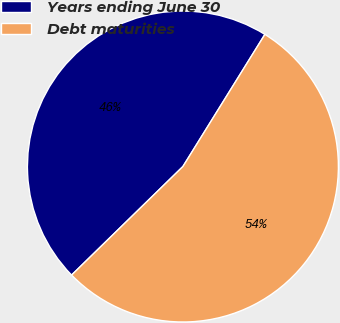Convert chart. <chart><loc_0><loc_0><loc_500><loc_500><pie_chart><fcel>Years ending June 30<fcel>Debt maturities<nl><fcel>46.14%<fcel>53.86%<nl></chart> 